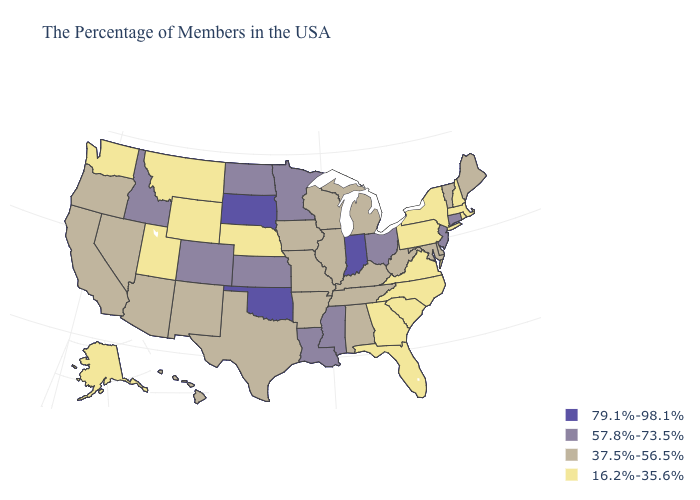What is the lowest value in the MidWest?
Keep it brief. 16.2%-35.6%. What is the value of Tennessee?
Short answer required. 37.5%-56.5%. Name the states that have a value in the range 57.8%-73.5%?
Answer briefly. Connecticut, New Jersey, Ohio, Mississippi, Louisiana, Minnesota, Kansas, North Dakota, Colorado, Idaho. What is the highest value in states that border Utah?
Keep it brief. 57.8%-73.5%. Which states hav the highest value in the West?
Keep it brief. Colorado, Idaho. Name the states that have a value in the range 79.1%-98.1%?
Short answer required. Indiana, Oklahoma, South Dakota. Among the states that border Missouri , does Tennessee have the highest value?
Answer briefly. No. What is the lowest value in the USA?
Be succinct. 16.2%-35.6%. Which states have the highest value in the USA?
Quick response, please. Indiana, Oklahoma, South Dakota. Which states have the lowest value in the West?
Quick response, please. Wyoming, Utah, Montana, Washington, Alaska. What is the highest value in states that border Nevada?
Be succinct. 57.8%-73.5%. What is the highest value in the USA?
Short answer required. 79.1%-98.1%. Does Tennessee have a higher value than Alabama?
Write a very short answer. No. What is the value of Texas?
Answer briefly. 37.5%-56.5%. How many symbols are there in the legend?
Concise answer only. 4. 